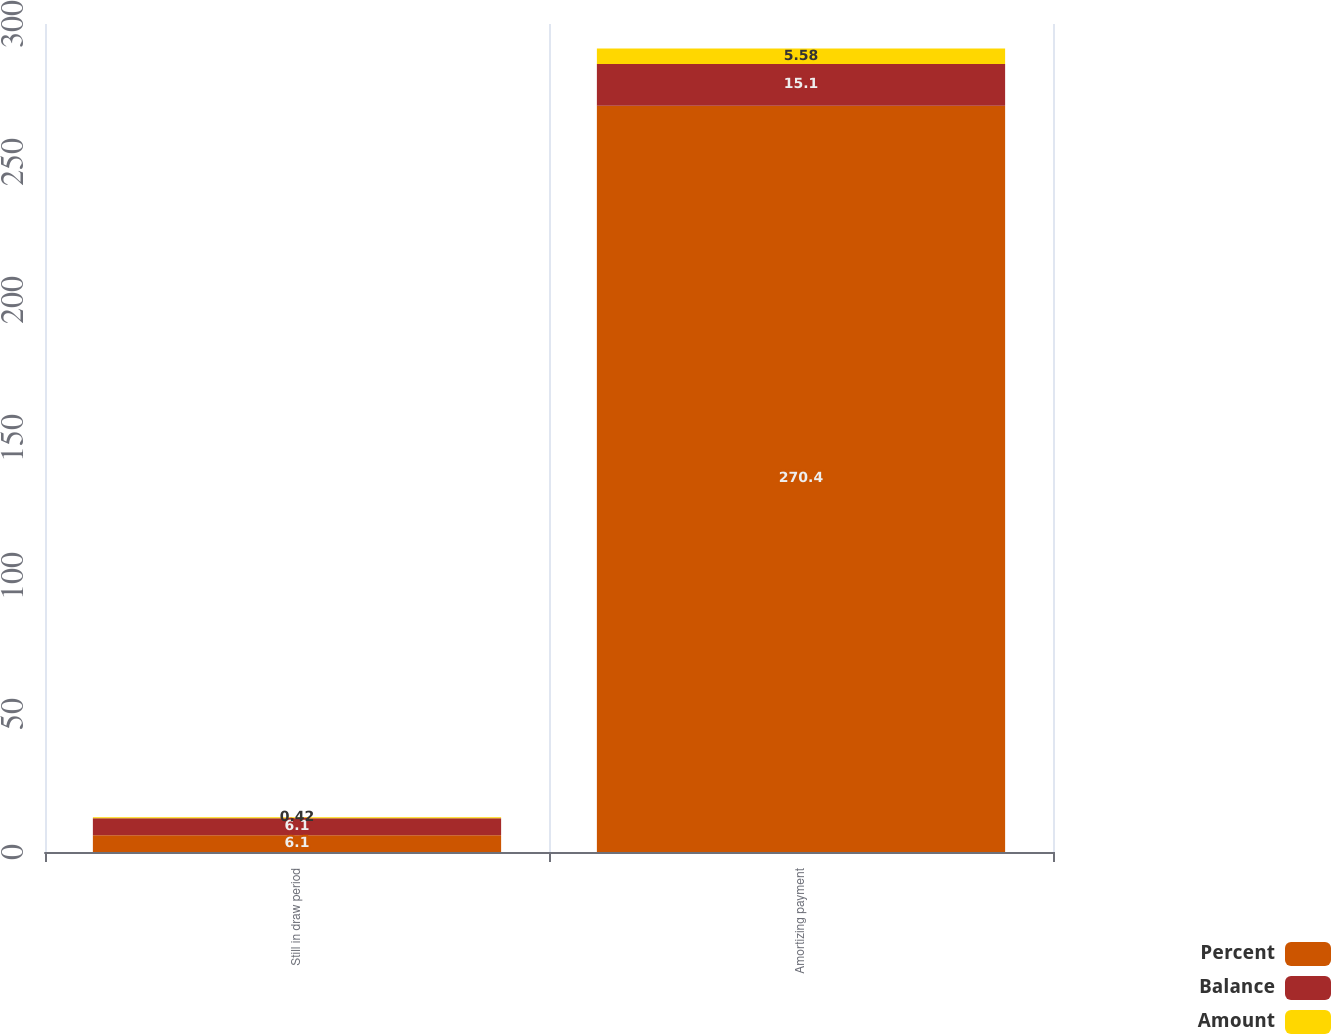<chart> <loc_0><loc_0><loc_500><loc_500><stacked_bar_chart><ecel><fcel>Still in draw period<fcel>Amortizing payment<nl><fcel>Percent<fcel>6.1<fcel>270.4<nl><fcel>Balance<fcel>6.1<fcel>15.1<nl><fcel>Amount<fcel>0.42<fcel>5.58<nl></chart> 